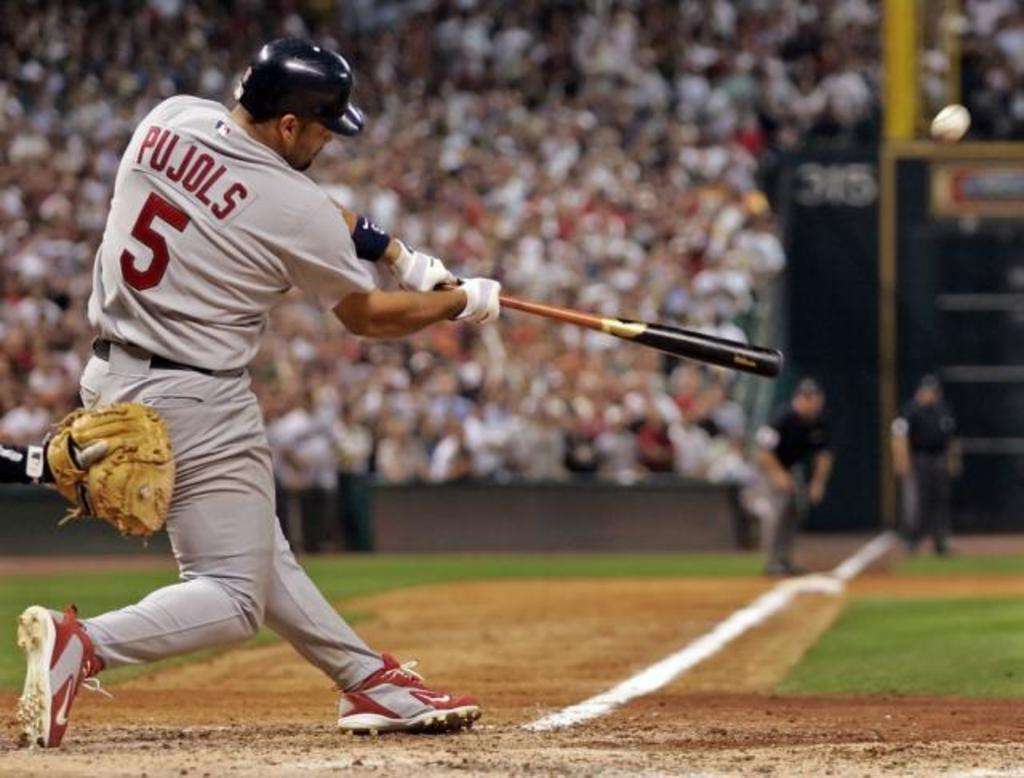<image>
Provide a brief description of the given image. a man named Pujols hitting a baseball in the game 